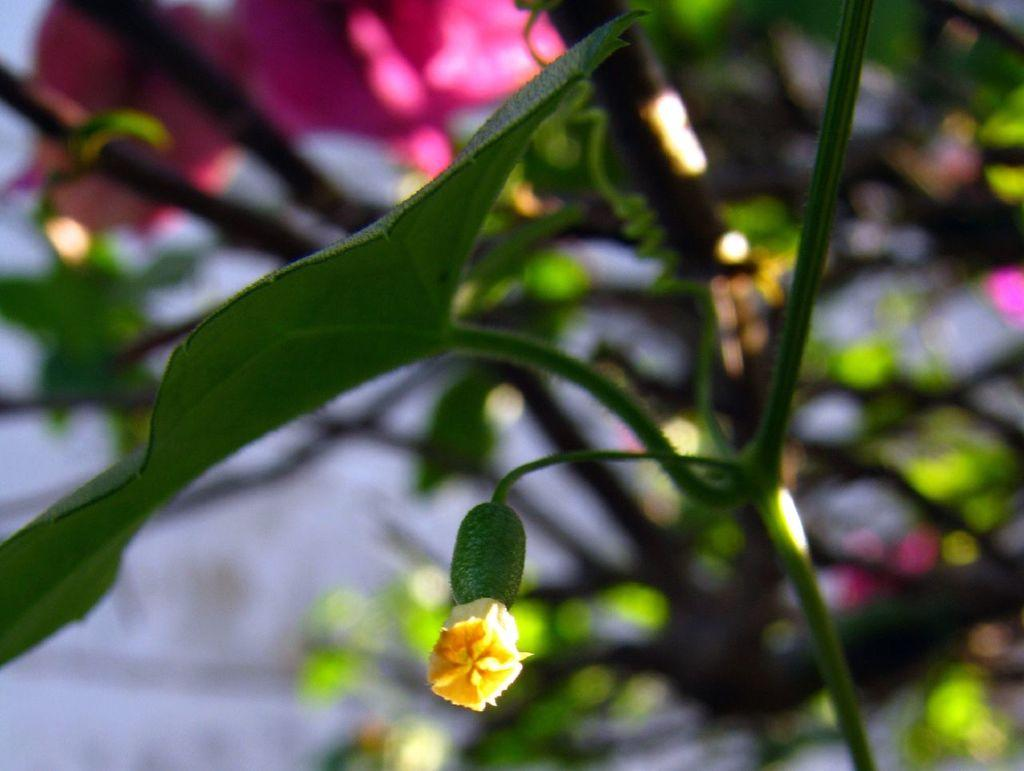What can be seen in the foreground of the picture? There are flowers, stems, and leaves in the foreground of the picture. How would you describe the background of the image? The background of the image is blurred. What is visible in the background of the picture? There are flowers and plants in the background of the picture. Can you tell me what type of ball is being used to play with the deer in the image? There is no ball or deer present in the image; it features flowers, stems, leaves, and plants in both the foreground and background. 